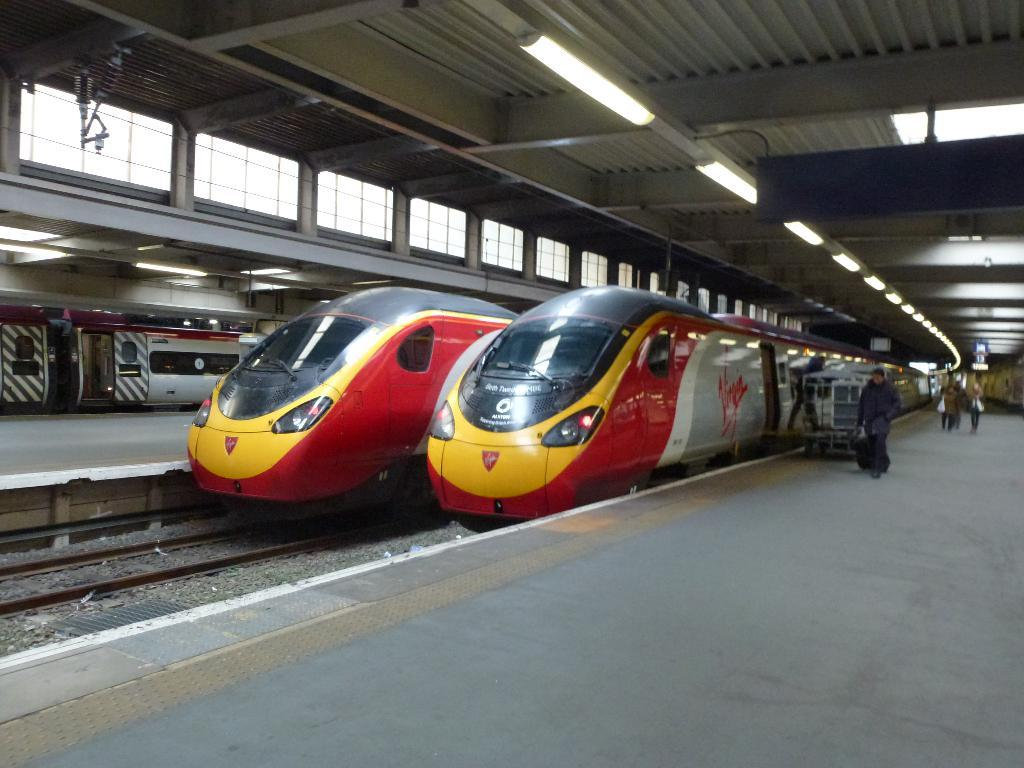<image>
Share a concise interpretation of the image provided. a train with the word Virgin on the side 